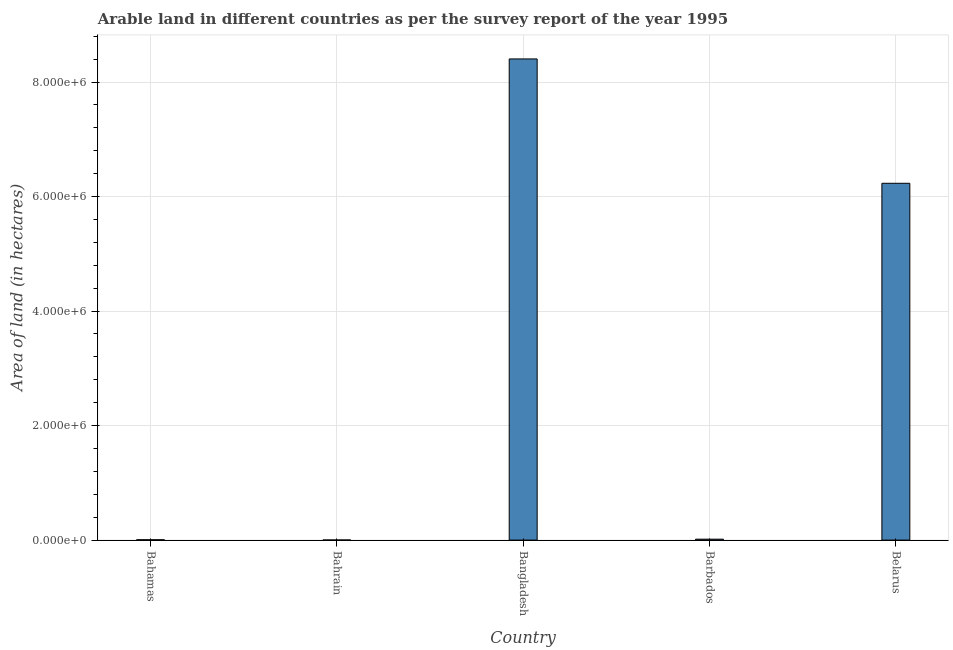Does the graph contain any zero values?
Offer a terse response. No. Does the graph contain grids?
Offer a terse response. Yes. What is the title of the graph?
Offer a terse response. Arable land in different countries as per the survey report of the year 1995. What is the label or title of the X-axis?
Keep it short and to the point. Country. What is the label or title of the Y-axis?
Offer a terse response. Area of land (in hectares). What is the area of land in Bahrain?
Provide a succinct answer. 2000. Across all countries, what is the maximum area of land?
Provide a succinct answer. 8.40e+06. Across all countries, what is the minimum area of land?
Make the answer very short. 2000. In which country was the area of land maximum?
Ensure brevity in your answer.  Bangladesh. In which country was the area of land minimum?
Offer a terse response. Bahrain. What is the sum of the area of land?
Provide a succinct answer. 1.47e+07. What is the difference between the area of land in Bahrain and Bangladesh?
Provide a succinct answer. -8.40e+06. What is the average area of land per country?
Offer a terse response. 2.93e+06. What is the median area of land?
Your answer should be very brief. 1.60e+04. What is the ratio of the area of land in Bangladesh to that in Belarus?
Ensure brevity in your answer.  1.35. What is the difference between the highest and the second highest area of land?
Make the answer very short. 2.17e+06. Is the sum of the area of land in Bahamas and Barbados greater than the maximum area of land across all countries?
Offer a terse response. No. What is the difference between the highest and the lowest area of land?
Keep it short and to the point. 8.40e+06. What is the Area of land (in hectares) of Bahamas?
Your response must be concise. 6000. What is the Area of land (in hectares) of Bahrain?
Your answer should be very brief. 2000. What is the Area of land (in hectares) in Bangladesh?
Ensure brevity in your answer.  8.40e+06. What is the Area of land (in hectares) in Barbados?
Provide a succinct answer. 1.60e+04. What is the Area of land (in hectares) in Belarus?
Your answer should be compact. 6.23e+06. What is the difference between the Area of land (in hectares) in Bahamas and Bahrain?
Give a very brief answer. 4000. What is the difference between the Area of land (in hectares) in Bahamas and Bangladesh?
Ensure brevity in your answer.  -8.40e+06. What is the difference between the Area of land (in hectares) in Bahamas and Belarus?
Ensure brevity in your answer.  -6.23e+06. What is the difference between the Area of land (in hectares) in Bahrain and Bangladesh?
Keep it short and to the point. -8.40e+06. What is the difference between the Area of land (in hectares) in Bahrain and Barbados?
Ensure brevity in your answer.  -1.40e+04. What is the difference between the Area of land (in hectares) in Bahrain and Belarus?
Offer a terse response. -6.23e+06. What is the difference between the Area of land (in hectares) in Bangladesh and Barbados?
Provide a succinct answer. 8.39e+06. What is the difference between the Area of land (in hectares) in Bangladesh and Belarus?
Keep it short and to the point. 2.17e+06. What is the difference between the Area of land (in hectares) in Barbados and Belarus?
Give a very brief answer. -6.22e+06. What is the ratio of the Area of land (in hectares) in Bahamas to that in Bahrain?
Give a very brief answer. 3. What is the ratio of the Area of land (in hectares) in Bahamas to that in Bangladesh?
Offer a terse response. 0. What is the ratio of the Area of land (in hectares) in Bahamas to that in Barbados?
Keep it short and to the point. 0.38. What is the ratio of the Area of land (in hectares) in Bahamas to that in Belarus?
Ensure brevity in your answer.  0. What is the ratio of the Area of land (in hectares) in Bahrain to that in Barbados?
Keep it short and to the point. 0.12. What is the ratio of the Area of land (in hectares) in Bahrain to that in Belarus?
Offer a terse response. 0. What is the ratio of the Area of land (in hectares) in Bangladesh to that in Barbados?
Your answer should be very brief. 525.25. What is the ratio of the Area of land (in hectares) in Bangladesh to that in Belarus?
Offer a very short reply. 1.35. What is the ratio of the Area of land (in hectares) in Barbados to that in Belarus?
Your answer should be compact. 0. 